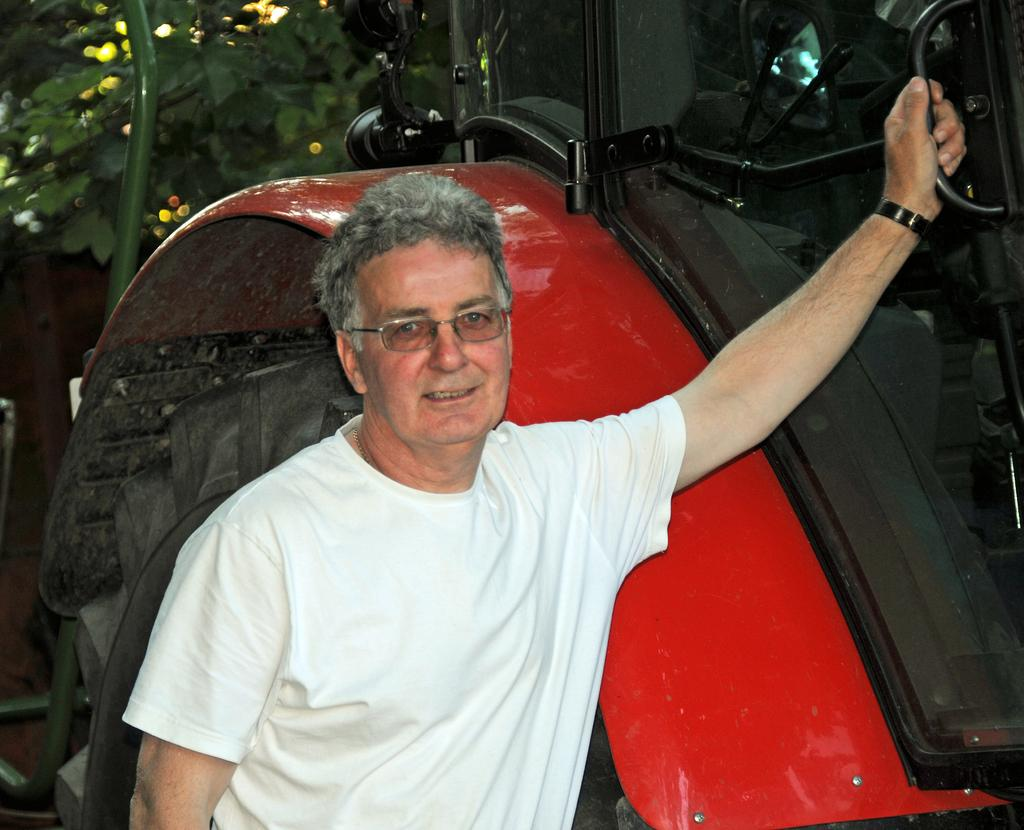What is the main subject in the image? There is a man standing in the image. What can be seen besides the man in the image? There is a red color vehicle in the image. What type of vegetation is visible in the background of the image? There is a green plant in the background of the image. What type of bread is the man holding in the image? There is no bread present in the image. 